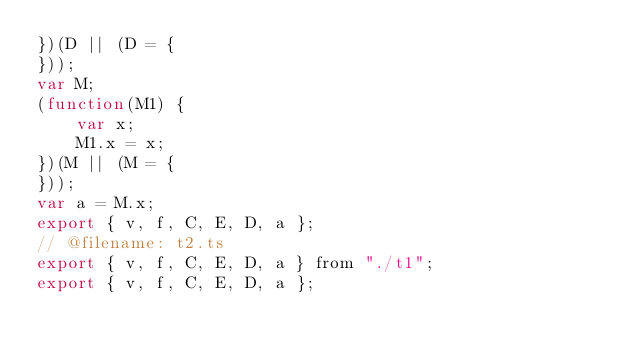<code> <loc_0><loc_0><loc_500><loc_500><_JavaScript_>})(D || (D = {
}));
var M;
(function(M1) {
    var x;
    M1.x = x;
})(M || (M = {
}));
var a = M.x;
export { v, f, C, E, D, a };
// @filename: t2.ts
export { v, f, C, E, D, a } from "./t1";
export { v, f, C, E, D, a };
</code> 